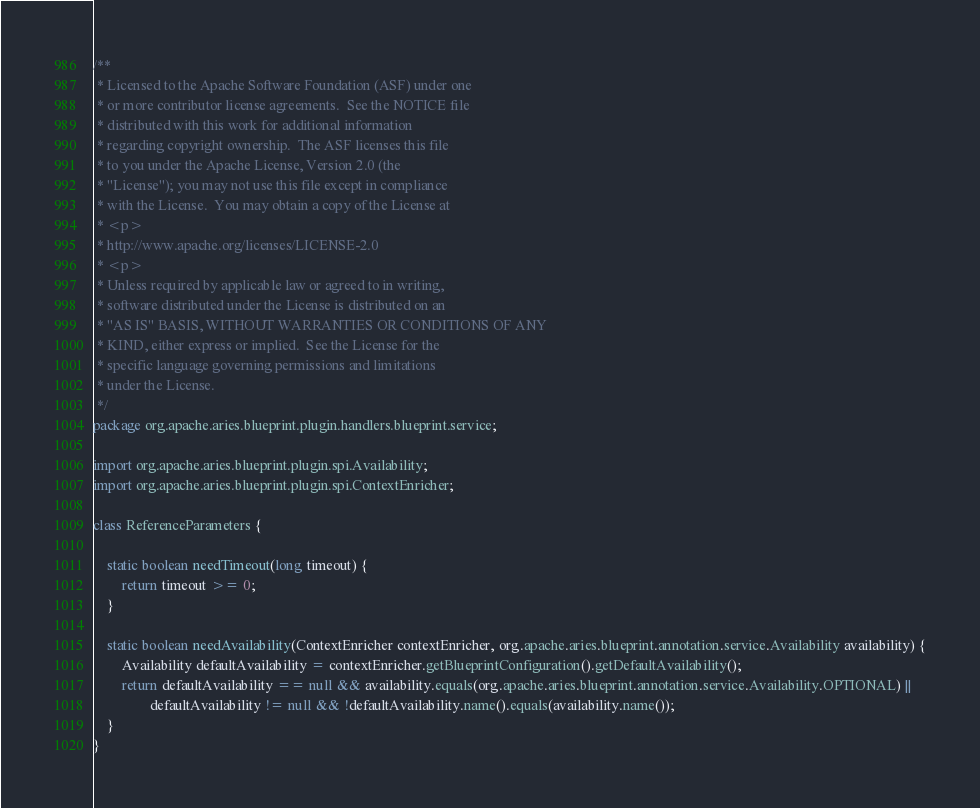<code> <loc_0><loc_0><loc_500><loc_500><_Java_>/**
 * Licensed to the Apache Software Foundation (ASF) under one
 * or more contributor license agreements.  See the NOTICE file
 * distributed with this work for additional information
 * regarding copyright ownership.  The ASF licenses this file
 * to you under the Apache License, Version 2.0 (the
 * "License"); you may not use this file except in compliance
 * with the License.  You may obtain a copy of the License at
 * <p>
 * http://www.apache.org/licenses/LICENSE-2.0
 * <p>
 * Unless required by applicable law or agreed to in writing,
 * software distributed under the License is distributed on an
 * "AS IS" BASIS, WITHOUT WARRANTIES OR CONDITIONS OF ANY
 * KIND, either express or implied.  See the License for the
 * specific language governing permissions and limitations
 * under the License.
 */
package org.apache.aries.blueprint.plugin.handlers.blueprint.service;

import org.apache.aries.blueprint.plugin.spi.Availability;
import org.apache.aries.blueprint.plugin.spi.ContextEnricher;

class ReferenceParameters {

    static boolean needTimeout(long timeout) {
        return timeout >= 0;
    }

    static boolean needAvailability(ContextEnricher contextEnricher, org.apache.aries.blueprint.annotation.service.Availability availability) {
        Availability defaultAvailability = contextEnricher.getBlueprintConfiguration().getDefaultAvailability();
        return defaultAvailability == null && availability.equals(org.apache.aries.blueprint.annotation.service.Availability.OPTIONAL) ||
                defaultAvailability != null && !defaultAvailability.name().equals(availability.name());
    }
}
</code> 